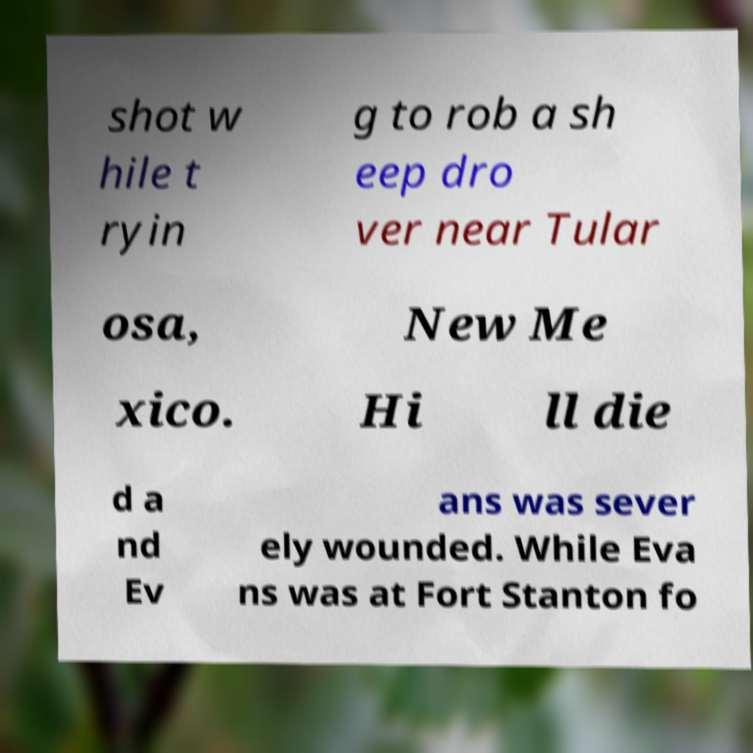For documentation purposes, I need the text within this image transcribed. Could you provide that? shot w hile t ryin g to rob a sh eep dro ver near Tular osa, New Me xico. Hi ll die d a nd Ev ans was sever ely wounded. While Eva ns was at Fort Stanton fo 